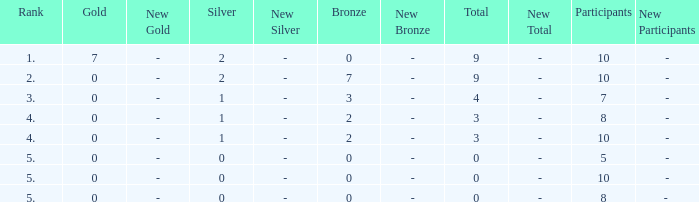What is listed as the highest Participants that also have a Rank of 5, and Silver that's smaller than 0? None. 